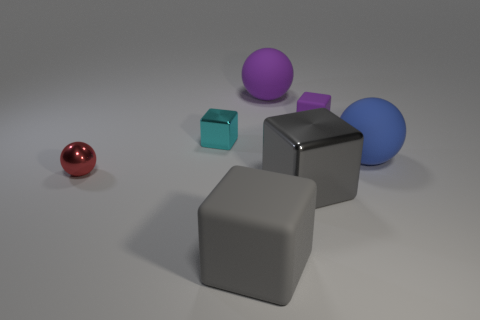The small block that is made of the same material as the big purple ball is what color?
Offer a terse response. Purple. How many things are the same material as the purple block?
Your answer should be compact. 3. There is a metal thing that is on the right side of the large matte cube; is it the same size as the metal cube that is behind the shiny sphere?
Offer a terse response. No. What material is the small cube left of the ball behind the cyan object?
Offer a very short reply. Metal. Are there fewer large gray matte objects that are behind the purple cube than matte blocks that are behind the big gray metallic cube?
Provide a succinct answer. Yes. There is a big object that is the same color as the big rubber cube; what material is it?
Keep it short and to the point. Metal. There is a small thing to the left of the cyan thing; what is it made of?
Your answer should be very brief. Metal. There is a cyan thing; are there any small cyan metal cubes on the right side of it?
Give a very brief answer. No. The red metal object is what shape?
Make the answer very short. Sphere. How many objects are either purple rubber things behind the purple rubber cube or large gray shiny cubes?
Your answer should be compact. 2. 